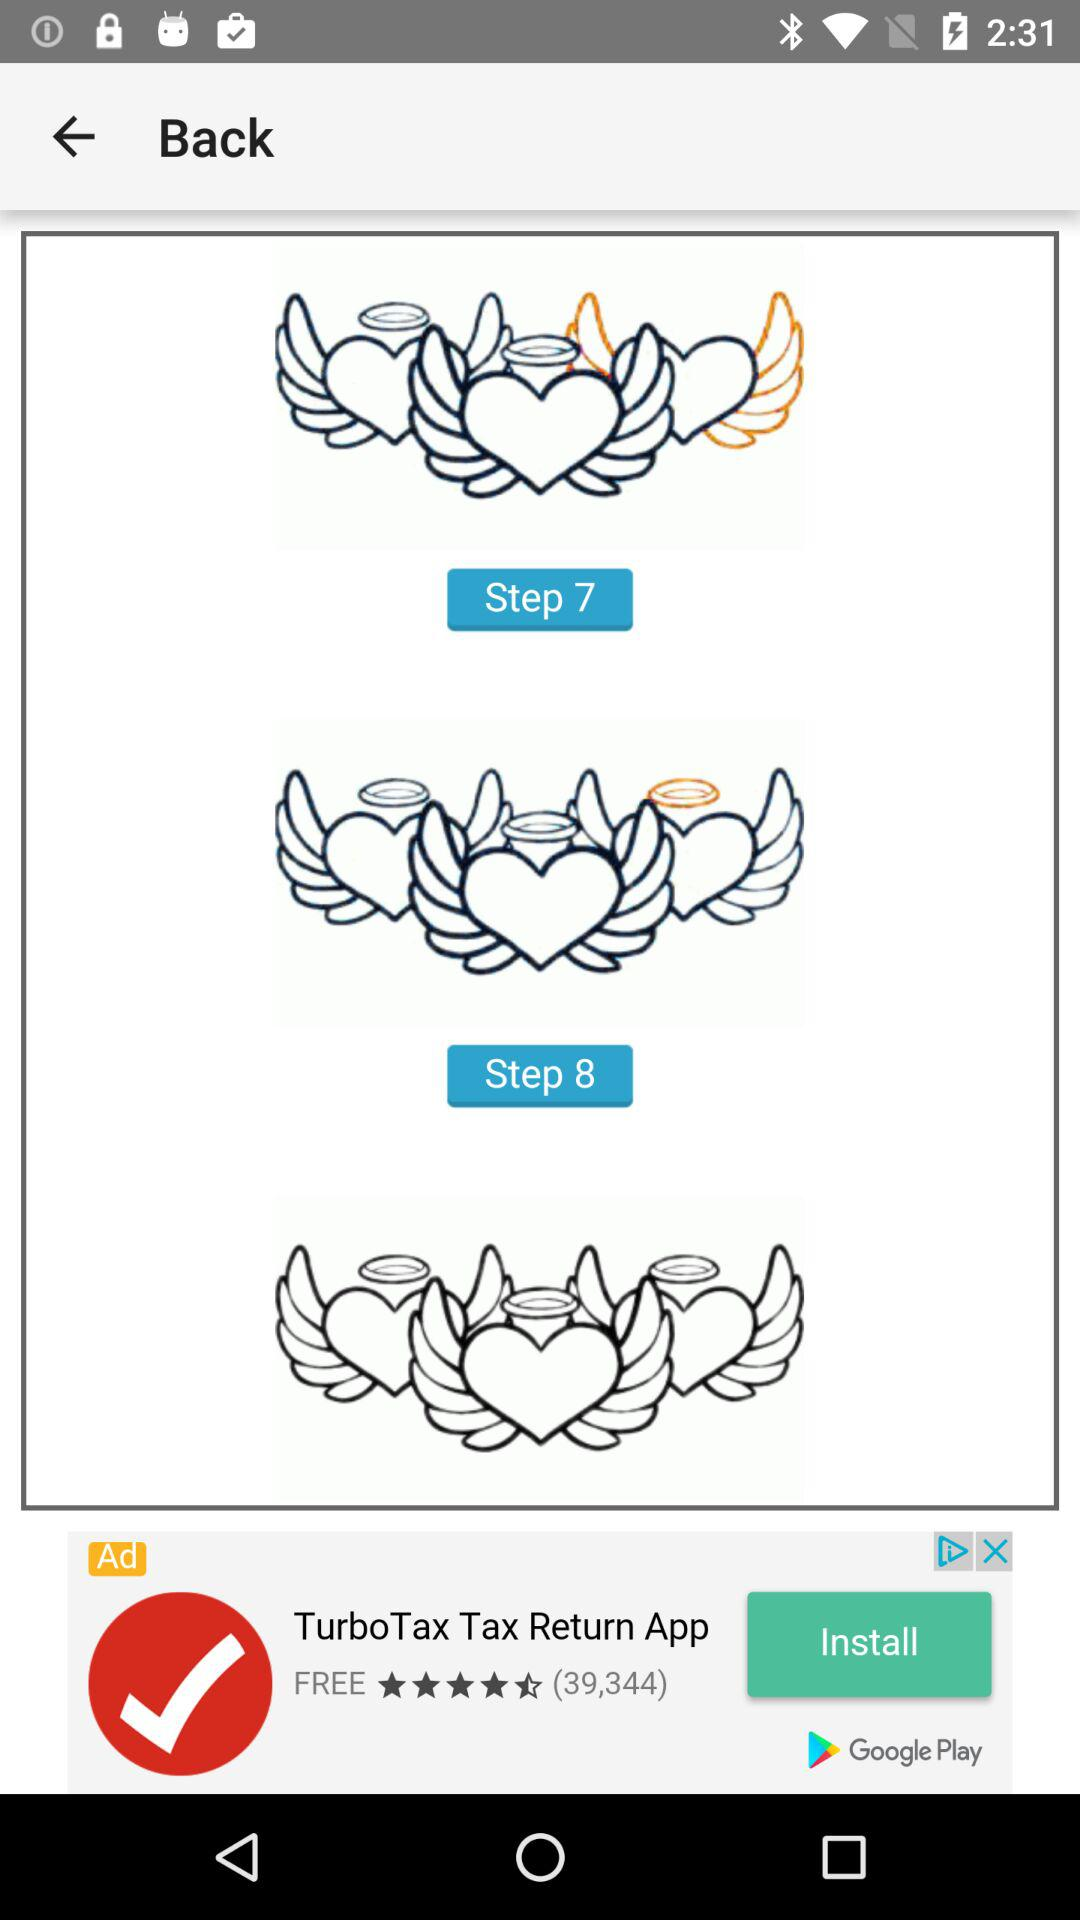How many steps are there in this progress bar?
Answer the question using a single word or phrase. 8 